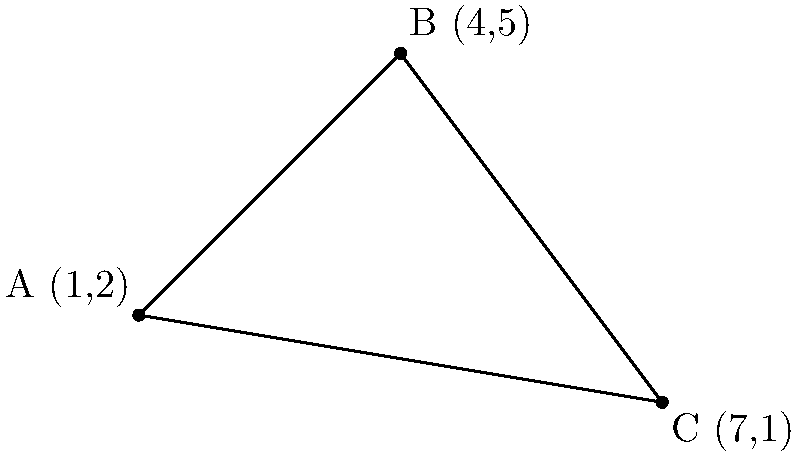Consider the following coordinate plane representing the impact of three presidential speeches on different literary genres. Point A (1,2) represents Lincoln's Gettysburg Address and its influence on historical fiction, point B (4,5) represents Kennedy's Inaugural Address and its impact on poetry, and point C (7,1) represents Reagan's "Tear Down This Wall" speech and its effect on political thrillers. Calculate the area of the triangle formed by these three points to determine the overall literary impact of these speeches. To find the area of a triangle given three coordinates, we can use the formula:

$$Area = \frac{1}{2}|x_1(y_2 - y_3) + x_2(y_3 - y_1) + x_3(y_1 - y_2)|$$

Where $(x_1, y_1)$, $(x_2, y_2)$, and $(x_3, y_3)$ are the coordinates of the three points.

Given:
A (1,2), B (4,5), C (7,1)

Step 1: Substitute the values into the formula:
$$Area = \frac{1}{2}|1(5 - 1) + 4(1 - 2) + 7(2 - 5)|$$

Step 2: Simplify the expressions inside the parentheses:
$$Area = \frac{1}{2}|1(4) + 4(-1) + 7(-3)|$$

Step 3: Multiply:
$$Area = \frac{1}{2}|4 - 4 - 21|$$

Step 4: Add the terms inside the absolute value signs:
$$Area = \frac{1}{2}|-21|$$

Step 5: Simplify:
$$Area = \frac{1}{2}(21) = 10.5$$

Therefore, the area of the triangle is 10.5 square units, representing the magnitude of the combined literary impact of these three presidential speeches.
Answer: 10.5 square units 